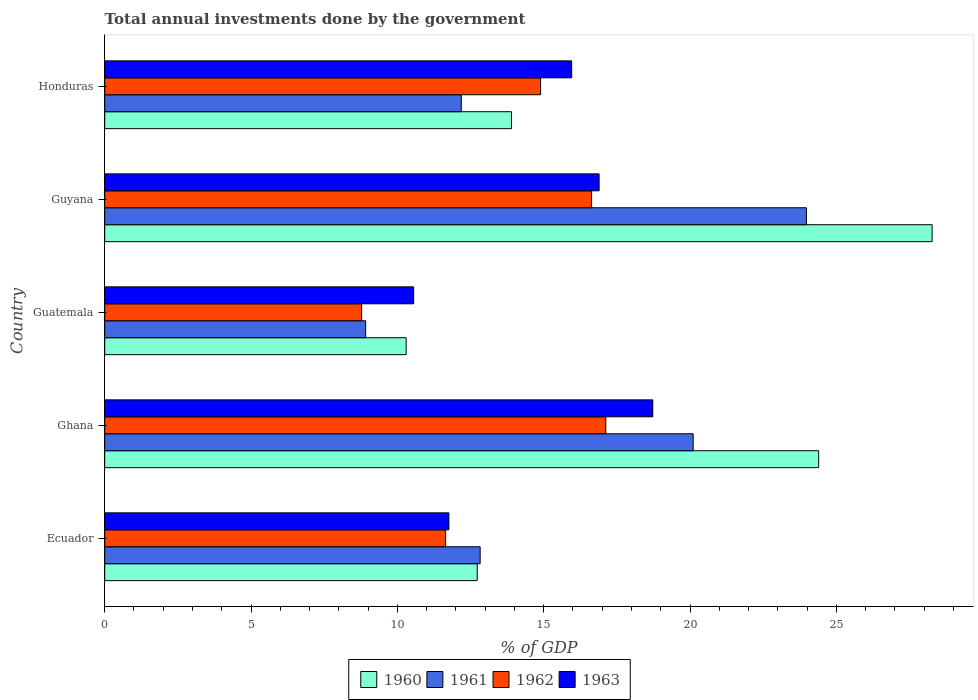Are the number of bars per tick equal to the number of legend labels?
Offer a very short reply. Yes. How many bars are there on the 2nd tick from the bottom?
Provide a succinct answer. 4. What is the label of the 1st group of bars from the top?
Provide a succinct answer. Honduras. In how many cases, is the number of bars for a given country not equal to the number of legend labels?
Give a very brief answer. 0. What is the total annual investments done by the government in 1960 in Ghana?
Ensure brevity in your answer.  24.4. Across all countries, what is the maximum total annual investments done by the government in 1963?
Your answer should be compact. 18.73. Across all countries, what is the minimum total annual investments done by the government in 1961?
Ensure brevity in your answer.  8.92. In which country was the total annual investments done by the government in 1961 maximum?
Make the answer very short. Guyana. In which country was the total annual investments done by the government in 1963 minimum?
Give a very brief answer. Guatemala. What is the total total annual investments done by the government in 1961 in the graph?
Provide a short and direct response. 78.02. What is the difference between the total annual investments done by the government in 1961 in Ecuador and that in Guatemala?
Give a very brief answer. 3.91. What is the difference between the total annual investments done by the government in 1961 in Ghana and the total annual investments done by the government in 1962 in Guatemala?
Offer a very short reply. 11.33. What is the average total annual investments done by the government in 1963 per country?
Keep it short and to the point. 14.78. What is the difference between the total annual investments done by the government in 1960 and total annual investments done by the government in 1961 in Ghana?
Give a very brief answer. 4.29. What is the ratio of the total annual investments done by the government in 1960 in Guatemala to that in Honduras?
Your response must be concise. 0.74. What is the difference between the highest and the second highest total annual investments done by the government in 1963?
Your response must be concise. 1.83. What is the difference between the highest and the lowest total annual investments done by the government in 1960?
Provide a short and direct response. 17.97. In how many countries, is the total annual investments done by the government in 1963 greater than the average total annual investments done by the government in 1963 taken over all countries?
Provide a succinct answer. 3. Is it the case that in every country, the sum of the total annual investments done by the government in 1962 and total annual investments done by the government in 1960 is greater than the sum of total annual investments done by the government in 1963 and total annual investments done by the government in 1961?
Your response must be concise. No. What does the 1st bar from the bottom in Guyana represents?
Offer a terse response. 1960. Is it the case that in every country, the sum of the total annual investments done by the government in 1962 and total annual investments done by the government in 1963 is greater than the total annual investments done by the government in 1960?
Offer a very short reply. Yes. Are all the bars in the graph horizontal?
Provide a short and direct response. Yes. What is the difference between two consecutive major ticks on the X-axis?
Your response must be concise. 5. Are the values on the major ticks of X-axis written in scientific E-notation?
Your answer should be compact. No. Does the graph contain any zero values?
Give a very brief answer. No. How are the legend labels stacked?
Make the answer very short. Horizontal. What is the title of the graph?
Offer a terse response. Total annual investments done by the government. Does "1985" appear as one of the legend labels in the graph?
Provide a short and direct response. No. What is the label or title of the X-axis?
Give a very brief answer. % of GDP. What is the % of GDP of 1960 in Ecuador?
Provide a succinct answer. 12.73. What is the % of GDP of 1961 in Ecuador?
Your answer should be compact. 12.83. What is the % of GDP of 1962 in Ecuador?
Your response must be concise. 11.65. What is the % of GDP in 1963 in Ecuador?
Provide a succinct answer. 11.76. What is the % of GDP of 1960 in Ghana?
Offer a terse response. 24.4. What is the % of GDP in 1961 in Ghana?
Keep it short and to the point. 20.11. What is the % of GDP of 1962 in Ghana?
Your answer should be very brief. 17.12. What is the % of GDP in 1963 in Ghana?
Give a very brief answer. 18.73. What is the % of GDP of 1960 in Guatemala?
Your answer should be very brief. 10.3. What is the % of GDP in 1961 in Guatemala?
Make the answer very short. 8.92. What is the % of GDP in 1962 in Guatemala?
Your answer should be very brief. 8.78. What is the % of GDP of 1963 in Guatemala?
Ensure brevity in your answer.  10.56. What is the % of GDP in 1960 in Guyana?
Provide a succinct answer. 28.27. What is the % of GDP in 1961 in Guyana?
Offer a terse response. 23.98. What is the % of GDP of 1962 in Guyana?
Your answer should be compact. 16.64. What is the % of GDP in 1963 in Guyana?
Provide a short and direct response. 16.89. What is the % of GDP in 1960 in Honduras?
Your answer should be compact. 13.9. What is the % of GDP in 1961 in Honduras?
Your response must be concise. 12.18. What is the % of GDP of 1962 in Honduras?
Your answer should be very brief. 14.89. What is the % of GDP of 1963 in Honduras?
Your answer should be compact. 15.96. Across all countries, what is the maximum % of GDP in 1960?
Make the answer very short. 28.27. Across all countries, what is the maximum % of GDP in 1961?
Your answer should be very brief. 23.98. Across all countries, what is the maximum % of GDP of 1962?
Make the answer very short. 17.12. Across all countries, what is the maximum % of GDP of 1963?
Offer a terse response. 18.73. Across all countries, what is the minimum % of GDP of 1960?
Provide a succinct answer. 10.3. Across all countries, what is the minimum % of GDP in 1961?
Offer a very short reply. 8.92. Across all countries, what is the minimum % of GDP in 1962?
Your answer should be compact. 8.78. Across all countries, what is the minimum % of GDP in 1963?
Your response must be concise. 10.56. What is the total % of GDP of 1960 in the graph?
Ensure brevity in your answer.  89.6. What is the total % of GDP in 1961 in the graph?
Offer a very short reply. 78.02. What is the total % of GDP of 1962 in the graph?
Provide a short and direct response. 69.08. What is the total % of GDP in 1963 in the graph?
Offer a very short reply. 73.89. What is the difference between the % of GDP of 1960 in Ecuador and that in Ghana?
Provide a short and direct response. -11.67. What is the difference between the % of GDP of 1961 in Ecuador and that in Ghana?
Your answer should be very brief. -7.28. What is the difference between the % of GDP in 1962 in Ecuador and that in Ghana?
Give a very brief answer. -5.48. What is the difference between the % of GDP of 1963 in Ecuador and that in Ghana?
Make the answer very short. -6.97. What is the difference between the % of GDP in 1960 in Ecuador and that in Guatemala?
Give a very brief answer. 2.43. What is the difference between the % of GDP in 1961 in Ecuador and that in Guatemala?
Your response must be concise. 3.91. What is the difference between the % of GDP in 1962 in Ecuador and that in Guatemala?
Keep it short and to the point. 2.87. What is the difference between the % of GDP of 1963 in Ecuador and that in Guatemala?
Give a very brief answer. 1.2. What is the difference between the % of GDP in 1960 in Ecuador and that in Guyana?
Make the answer very short. -15.54. What is the difference between the % of GDP in 1961 in Ecuador and that in Guyana?
Offer a terse response. -11.15. What is the difference between the % of GDP of 1962 in Ecuador and that in Guyana?
Make the answer very short. -4.99. What is the difference between the % of GDP of 1963 in Ecuador and that in Guyana?
Ensure brevity in your answer.  -5.13. What is the difference between the % of GDP of 1960 in Ecuador and that in Honduras?
Offer a very short reply. -1.17. What is the difference between the % of GDP in 1961 in Ecuador and that in Honduras?
Offer a terse response. 0.64. What is the difference between the % of GDP in 1962 in Ecuador and that in Honduras?
Your response must be concise. -3.25. What is the difference between the % of GDP of 1963 in Ecuador and that in Honduras?
Make the answer very short. -4.2. What is the difference between the % of GDP of 1960 in Ghana and that in Guatemala?
Offer a terse response. 14.1. What is the difference between the % of GDP in 1961 in Ghana and that in Guatemala?
Give a very brief answer. 11.19. What is the difference between the % of GDP in 1962 in Ghana and that in Guatemala?
Make the answer very short. 8.34. What is the difference between the % of GDP in 1963 in Ghana and that in Guatemala?
Keep it short and to the point. 8.17. What is the difference between the % of GDP in 1960 in Ghana and that in Guyana?
Your answer should be compact. -3.88. What is the difference between the % of GDP of 1961 in Ghana and that in Guyana?
Make the answer very short. -3.87. What is the difference between the % of GDP of 1962 in Ghana and that in Guyana?
Your answer should be compact. 0.49. What is the difference between the % of GDP of 1963 in Ghana and that in Guyana?
Keep it short and to the point. 1.83. What is the difference between the % of GDP of 1960 in Ghana and that in Honduras?
Offer a terse response. 10.5. What is the difference between the % of GDP of 1961 in Ghana and that in Honduras?
Your response must be concise. 7.92. What is the difference between the % of GDP of 1962 in Ghana and that in Honduras?
Keep it short and to the point. 2.23. What is the difference between the % of GDP of 1963 in Ghana and that in Honduras?
Offer a very short reply. 2.77. What is the difference between the % of GDP of 1960 in Guatemala and that in Guyana?
Give a very brief answer. -17.97. What is the difference between the % of GDP in 1961 in Guatemala and that in Guyana?
Your response must be concise. -15.06. What is the difference between the % of GDP of 1962 in Guatemala and that in Guyana?
Offer a terse response. -7.86. What is the difference between the % of GDP of 1963 in Guatemala and that in Guyana?
Offer a terse response. -6.34. What is the difference between the % of GDP in 1960 in Guatemala and that in Honduras?
Provide a short and direct response. -3.6. What is the difference between the % of GDP in 1961 in Guatemala and that in Honduras?
Provide a short and direct response. -3.27. What is the difference between the % of GDP in 1962 in Guatemala and that in Honduras?
Offer a very short reply. -6.11. What is the difference between the % of GDP in 1963 in Guatemala and that in Honduras?
Provide a short and direct response. -5.4. What is the difference between the % of GDP in 1960 in Guyana and that in Honduras?
Make the answer very short. 14.37. What is the difference between the % of GDP in 1961 in Guyana and that in Honduras?
Your answer should be very brief. 11.8. What is the difference between the % of GDP of 1962 in Guyana and that in Honduras?
Your response must be concise. 1.74. What is the difference between the % of GDP in 1963 in Guyana and that in Honduras?
Make the answer very short. 0.94. What is the difference between the % of GDP of 1960 in Ecuador and the % of GDP of 1961 in Ghana?
Offer a very short reply. -7.38. What is the difference between the % of GDP of 1960 in Ecuador and the % of GDP of 1962 in Ghana?
Your response must be concise. -4.39. What is the difference between the % of GDP of 1960 in Ecuador and the % of GDP of 1963 in Ghana?
Offer a terse response. -6. What is the difference between the % of GDP in 1961 in Ecuador and the % of GDP in 1962 in Ghana?
Give a very brief answer. -4.29. What is the difference between the % of GDP in 1961 in Ecuador and the % of GDP in 1963 in Ghana?
Give a very brief answer. -5.9. What is the difference between the % of GDP of 1962 in Ecuador and the % of GDP of 1963 in Ghana?
Give a very brief answer. -7.08. What is the difference between the % of GDP of 1960 in Ecuador and the % of GDP of 1961 in Guatemala?
Provide a succinct answer. 3.81. What is the difference between the % of GDP of 1960 in Ecuador and the % of GDP of 1962 in Guatemala?
Your answer should be compact. 3.95. What is the difference between the % of GDP of 1960 in Ecuador and the % of GDP of 1963 in Guatemala?
Your answer should be compact. 2.17. What is the difference between the % of GDP of 1961 in Ecuador and the % of GDP of 1962 in Guatemala?
Provide a short and direct response. 4.05. What is the difference between the % of GDP of 1961 in Ecuador and the % of GDP of 1963 in Guatemala?
Make the answer very short. 2.27. What is the difference between the % of GDP in 1962 in Ecuador and the % of GDP in 1963 in Guatemala?
Offer a terse response. 1.09. What is the difference between the % of GDP of 1960 in Ecuador and the % of GDP of 1961 in Guyana?
Provide a short and direct response. -11.25. What is the difference between the % of GDP of 1960 in Ecuador and the % of GDP of 1962 in Guyana?
Offer a very short reply. -3.91. What is the difference between the % of GDP in 1960 in Ecuador and the % of GDP in 1963 in Guyana?
Your answer should be very brief. -4.17. What is the difference between the % of GDP in 1961 in Ecuador and the % of GDP in 1962 in Guyana?
Offer a terse response. -3.81. What is the difference between the % of GDP in 1961 in Ecuador and the % of GDP in 1963 in Guyana?
Your answer should be very brief. -4.06. What is the difference between the % of GDP of 1962 in Ecuador and the % of GDP of 1963 in Guyana?
Ensure brevity in your answer.  -5.25. What is the difference between the % of GDP of 1960 in Ecuador and the % of GDP of 1961 in Honduras?
Provide a succinct answer. 0.54. What is the difference between the % of GDP in 1960 in Ecuador and the % of GDP in 1962 in Honduras?
Give a very brief answer. -2.17. What is the difference between the % of GDP in 1960 in Ecuador and the % of GDP in 1963 in Honduras?
Offer a terse response. -3.23. What is the difference between the % of GDP of 1961 in Ecuador and the % of GDP of 1962 in Honduras?
Ensure brevity in your answer.  -2.06. What is the difference between the % of GDP in 1961 in Ecuador and the % of GDP in 1963 in Honduras?
Ensure brevity in your answer.  -3.13. What is the difference between the % of GDP in 1962 in Ecuador and the % of GDP in 1963 in Honduras?
Your answer should be compact. -4.31. What is the difference between the % of GDP in 1960 in Ghana and the % of GDP in 1961 in Guatemala?
Your answer should be compact. 15.48. What is the difference between the % of GDP of 1960 in Ghana and the % of GDP of 1962 in Guatemala?
Keep it short and to the point. 15.62. What is the difference between the % of GDP of 1960 in Ghana and the % of GDP of 1963 in Guatemala?
Offer a very short reply. 13.84. What is the difference between the % of GDP of 1961 in Ghana and the % of GDP of 1962 in Guatemala?
Your answer should be compact. 11.33. What is the difference between the % of GDP of 1961 in Ghana and the % of GDP of 1963 in Guatemala?
Ensure brevity in your answer.  9.55. What is the difference between the % of GDP of 1962 in Ghana and the % of GDP of 1963 in Guatemala?
Your answer should be very brief. 6.57. What is the difference between the % of GDP in 1960 in Ghana and the % of GDP in 1961 in Guyana?
Your answer should be compact. 0.42. What is the difference between the % of GDP in 1960 in Ghana and the % of GDP in 1962 in Guyana?
Your answer should be compact. 7.76. What is the difference between the % of GDP in 1960 in Ghana and the % of GDP in 1963 in Guyana?
Give a very brief answer. 7.5. What is the difference between the % of GDP in 1961 in Ghana and the % of GDP in 1962 in Guyana?
Provide a short and direct response. 3.47. What is the difference between the % of GDP of 1961 in Ghana and the % of GDP of 1963 in Guyana?
Make the answer very short. 3.21. What is the difference between the % of GDP of 1962 in Ghana and the % of GDP of 1963 in Guyana?
Your answer should be compact. 0.23. What is the difference between the % of GDP of 1960 in Ghana and the % of GDP of 1961 in Honduras?
Your answer should be compact. 12.21. What is the difference between the % of GDP in 1960 in Ghana and the % of GDP in 1962 in Honduras?
Provide a short and direct response. 9.5. What is the difference between the % of GDP in 1960 in Ghana and the % of GDP in 1963 in Honduras?
Your response must be concise. 8.44. What is the difference between the % of GDP in 1961 in Ghana and the % of GDP in 1962 in Honduras?
Offer a terse response. 5.21. What is the difference between the % of GDP in 1961 in Ghana and the % of GDP in 1963 in Honduras?
Keep it short and to the point. 4.15. What is the difference between the % of GDP in 1962 in Ghana and the % of GDP in 1963 in Honduras?
Give a very brief answer. 1.17. What is the difference between the % of GDP in 1960 in Guatemala and the % of GDP in 1961 in Guyana?
Provide a succinct answer. -13.68. What is the difference between the % of GDP in 1960 in Guatemala and the % of GDP in 1962 in Guyana?
Offer a terse response. -6.34. What is the difference between the % of GDP of 1960 in Guatemala and the % of GDP of 1963 in Guyana?
Give a very brief answer. -6.59. What is the difference between the % of GDP of 1961 in Guatemala and the % of GDP of 1962 in Guyana?
Provide a short and direct response. -7.72. What is the difference between the % of GDP of 1961 in Guatemala and the % of GDP of 1963 in Guyana?
Make the answer very short. -7.98. What is the difference between the % of GDP of 1962 in Guatemala and the % of GDP of 1963 in Guyana?
Keep it short and to the point. -8.11. What is the difference between the % of GDP in 1960 in Guatemala and the % of GDP in 1961 in Honduras?
Your answer should be very brief. -1.88. What is the difference between the % of GDP in 1960 in Guatemala and the % of GDP in 1962 in Honduras?
Offer a terse response. -4.59. What is the difference between the % of GDP in 1960 in Guatemala and the % of GDP in 1963 in Honduras?
Your answer should be very brief. -5.65. What is the difference between the % of GDP in 1961 in Guatemala and the % of GDP in 1962 in Honduras?
Keep it short and to the point. -5.98. What is the difference between the % of GDP of 1961 in Guatemala and the % of GDP of 1963 in Honduras?
Ensure brevity in your answer.  -7.04. What is the difference between the % of GDP in 1962 in Guatemala and the % of GDP in 1963 in Honduras?
Offer a terse response. -7.18. What is the difference between the % of GDP in 1960 in Guyana and the % of GDP in 1961 in Honduras?
Give a very brief answer. 16.09. What is the difference between the % of GDP in 1960 in Guyana and the % of GDP in 1962 in Honduras?
Keep it short and to the point. 13.38. What is the difference between the % of GDP in 1960 in Guyana and the % of GDP in 1963 in Honduras?
Give a very brief answer. 12.32. What is the difference between the % of GDP of 1961 in Guyana and the % of GDP of 1962 in Honduras?
Offer a very short reply. 9.09. What is the difference between the % of GDP in 1961 in Guyana and the % of GDP in 1963 in Honduras?
Keep it short and to the point. 8.02. What is the difference between the % of GDP in 1962 in Guyana and the % of GDP in 1963 in Honduras?
Your response must be concise. 0.68. What is the average % of GDP in 1960 per country?
Make the answer very short. 17.92. What is the average % of GDP in 1961 per country?
Offer a terse response. 15.6. What is the average % of GDP in 1962 per country?
Provide a succinct answer. 13.82. What is the average % of GDP of 1963 per country?
Keep it short and to the point. 14.78. What is the difference between the % of GDP of 1960 and % of GDP of 1961 in Ecuador?
Ensure brevity in your answer.  -0.1. What is the difference between the % of GDP of 1960 and % of GDP of 1962 in Ecuador?
Ensure brevity in your answer.  1.08. What is the difference between the % of GDP in 1960 and % of GDP in 1963 in Ecuador?
Offer a terse response. 0.97. What is the difference between the % of GDP of 1961 and % of GDP of 1962 in Ecuador?
Provide a succinct answer. 1.18. What is the difference between the % of GDP in 1961 and % of GDP in 1963 in Ecuador?
Give a very brief answer. 1.07. What is the difference between the % of GDP of 1962 and % of GDP of 1963 in Ecuador?
Your answer should be compact. -0.11. What is the difference between the % of GDP of 1960 and % of GDP of 1961 in Ghana?
Give a very brief answer. 4.29. What is the difference between the % of GDP in 1960 and % of GDP in 1962 in Ghana?
Provide a succinct answer. 7.27. What is the difference between the % of GDP in 1960 and % of GDP in 1963 in Ghana?
Provide a succinct answer. 5.67. What is the difference between the % of GDP in 1961 and % of GDP in 1962 in Ghana?
Offer a very short reply. 2.98. What is the difference between the % of GDP of 1961 and % of GDP of 1963 in Ghana?
Offer a very short reply. 1.38. What is the difference between the % of GDP in 1962 and % of GDP in 1963 in Ghana?
Your answer should be very brief. -1.6. What is the difference between the % of GDP in 1960 and % of GDP in 1961 in Guatemala?
Give a very brief answer. 1.38. What is the difference between the % of GDP of 1960 and % of GDP of 1962 in Guatemala?
Give a very brief answer. 1.52. What is the difference between the % of GDP of 1960 and % of GDP of 1963 in Guatemala?
Provide a succinct answer. -0.26. What is the difference between the % of GDP of 1961 and % of GDP of 1962 in Guatemala?
Give a very brief answer. 0.14. What is the difference between the % of GDP of 1961 and % of GDP of 1963 in Guatemala?
Ensure brevity in your answer.  -1.64. What is the difference between the % of GDP in 1962 and % of GDP in 1963 in Guatemala?
Your answer should be compact. -1.78. What is the difference between the % of GDP of 1960 and % of GDP of 1961 in Guyana?
Your answer should be very brief. 4.29. What is the difference between the % of GDP in 1960 and % of GDP in 1962 in Guyana?
Ensure brevity in your answer.  11.64. What is the difference between the % of GDP in 1960 and % of GDP in 1963 in Guyana?
Give a very brief answer. 11.38. What is the difference between the % of GDP in 1961 and % of GDP in 1962 in Guyana?
Keep it short and to the point. 7.34. What is the difference between the % of GDP of 1961 and % of GDP of 1963 in Guyana?
Keep it short and to the point. 7.09. What is the difference between the % of GDP in 1962 and % of GDP in 1963 in Guyana?
Your answer should be very brief. -0.26. What is the difference between the % of GDP in 1960 and % of GDP in 1961 in Honduras?
Your response must be concise. 1.71. What is the difference between the % of GDP of 1960 and % of GDP of 1962 in Honduras?
Your response must be concise. -1. What is the difference between the % of GDP in 1960 and % of GDP in 1963 in Honduras?
Offer a terse response. -2.06. What is the difference between the % of GDP of 1961 and % of GDP of 1962 in Honduras?
Ensure brevity in your answer.  -2.71. What is the difference between the % of GDP of 1961 and % of GDP of 1963 in Honduras?
Make the answer very short. -3.77. What is the difference between the % of GDP in 1962 and % of GDP in 1963 in Honduras?
Keep it short and to the point. -1.06. What is the ratio of the % of GDP in 1960 in Ecuador to that in Ghana?
Provide a succinct answer. 0.52. What is the ratio of the % of GDP in 1961 in Ecuador to that in Ghana?
Your answer should be very brief. 0.64. What is the ratio of the % of GDP of 1962 in Ecuador to that in Ghana?
Offer a terse response. 0.68. What is the ratio of the % of GDP in 1963 in Ecuador to that in Ghana?
Ensure brevity in your answer.  0.63. What is the ratio of the % of GDP in 1960 in Ecuador to that in Guatemala?
Keep it short and to the point. 1.24. What is the ratio of the % of GDP of 1961 in Ecuador to that in Guatemala?
Give a very brief answer. 1.44. What is the ratio of the % of GDP of 1962 in Ecuador to that in Guatemala?
Offer a very short reply. 1.33. What is the ratio of the % of GDP of 1963 in Ecuador to that in Guatemala?
Offer a very short reply. 1.11. What is the ratio of the % of GDP in 1960 in Ecuador to that in Guyana?
Your response must be concise. 0.45. What is the ratio of the % of GDP of 1961 in Ecuador to that in Guyana?
Your response must be concise. 0.54. What is the ratio of the % of GDP in 1962 in Ecuador to that in Guyana?
Offer a terse response. 0.7. What is the ratio of the % of GDP in 1963 in Ecuador to that in Guyana?
Your answer should be very brief. 0.7. What is the ratio of the % of GDP of 1960 in Ecuador to that in Honduras?
Provide a short and direct response. 0.92. What is the ratio of the % of GDP of 1961 in Ecuador to that in Honduras?
Keep it short and to the point. 1.05. What is the ratio of the % of GDP of 1962 in Ecuador to that in Honduras?
Provide a short and direct response. 0.78. What is the ratio of the % of GDP of 1963 in Ecuador to that in Honduras?
Provide a short and direct response. 0.74. What is the ratio of the % of GDP of 1960 in Ghana to that in Guatemala?
Provide a short and direct response. 2.37. What is the ratio of the % of GDP in 1961 in Ghana to that in Guatemala?
Offer a terse response. 2.26. What is the ratio of the % of GDP in 1962 in Ghana to that in Guatemala?
Your response must be concise. 1.95. What is the ratio of the % of GDP of 1963 in Ghana to that in Guatemala?
Provide a short and direct response. 1.77. What is the ratio of the % of GDP of 1960 in Ghana to that in Guyana?
Make the answer very short. 0.86. What is the ratio of the % of GDP of 1961 in Ghana to that in Guyana?
Make the answer very short. 0.84. What is the ratio of the % of GDP of 1962 in Ghana to that in Guyana?
Give a very brief answer. 1.03. What is the ratio of the % of GDP of 1963 in Ghana to that in Guyana?
Make the answer very short. 1.11. What is the ratio of the % of GDP of 1960 in Ghana to that in Honduras?
Your answer should be compact. 1.76. What is the ratio of the % of GDP in 1961 in Ghana to that in Honduras?
Provide a succinct answer. 1.65. What is the ratio of the % of GDP in 1962 in Ghana to that in Honduras?
Your response must be concise. 1.15. What is the ratio of the % of GDP in 1963 in Ghana to that in Honduras?
Your answer should be very brief. 1.17. What is the ratio of the % of GDP of 1960 in Guatemala to that in Guyana?
Make the answer very short. 0.36. What is the ratio of the % of GDP in 1961 in Guatemala to that in Guyana?
Offer a very short reply. 0.37. What is the ratio of the % of GDP of 1962 in Guatemala to that in Guyana?
Give a very brief answer. 0.53. What is the ratio of the % of GDP of 1963 in Guatemala to that in Guyana?
Make the answer very short. 0.62. What is the ratio of the % of GDP of 1960 in Guatemala to that in Honduras?
Give a very brief answer. 0.74. What is the ratio of the % of GDP of 1961 in Guatemala to that in Honduras?
Give a very brief answer. 0.73. What is the ratio of the % of GDP in 1962 in Guatemala to that in Honduras?
Provide a short and direct response. 0.59. What is the ratio of the % of GDP in 1963 in Guatemala to that in Honduras?
Provide a succinct answer. 0.66. What is the ratio of the % of GDP in 1960 in Guyana to that in Honduras?
Offer a very short reply. 2.03. What is the ratio of the % of GDP of 1961 in Guyana to that in Honduras?
Offer a very short reply. 1.97. What is the ratio of the % of GDP in 1962 in Guyana to that in Honduras?
Your response must be concise. 1.12. What is the ratio of the % of GDP of 1963 in Guyana to that in Honduras?
Provide a short and direct response. 1.06. What is the difference between the highest and the second highest % of GDP of 1960?
Offer a very short reply. 3.88. What is the difference between the highest and the second highest % of GDP of 1961?
Your answer should be very brief. 3.87. What is the difference between the highest and the second highest % of GDP of 1962?
Your response must be concise. 0.49. What is the difference between the highest and the second highest % of GDP in 1963?
Keep it short and to the point. 1.83. What is the difference between the highest and the lowest % of GDP in 1960?
Offer a very short reply. 17.97. What is the difference between the highest and the lowest % of GDP in 1961?
Offer a terse response. 15.06. What is the difference between the highest and the lowest % of GDP in 1962?
Provide a short and direct response. 8.34. What is the difference between the highest and the lowest % of GDP of 1963?
Your answer should be compact. 8.17. 